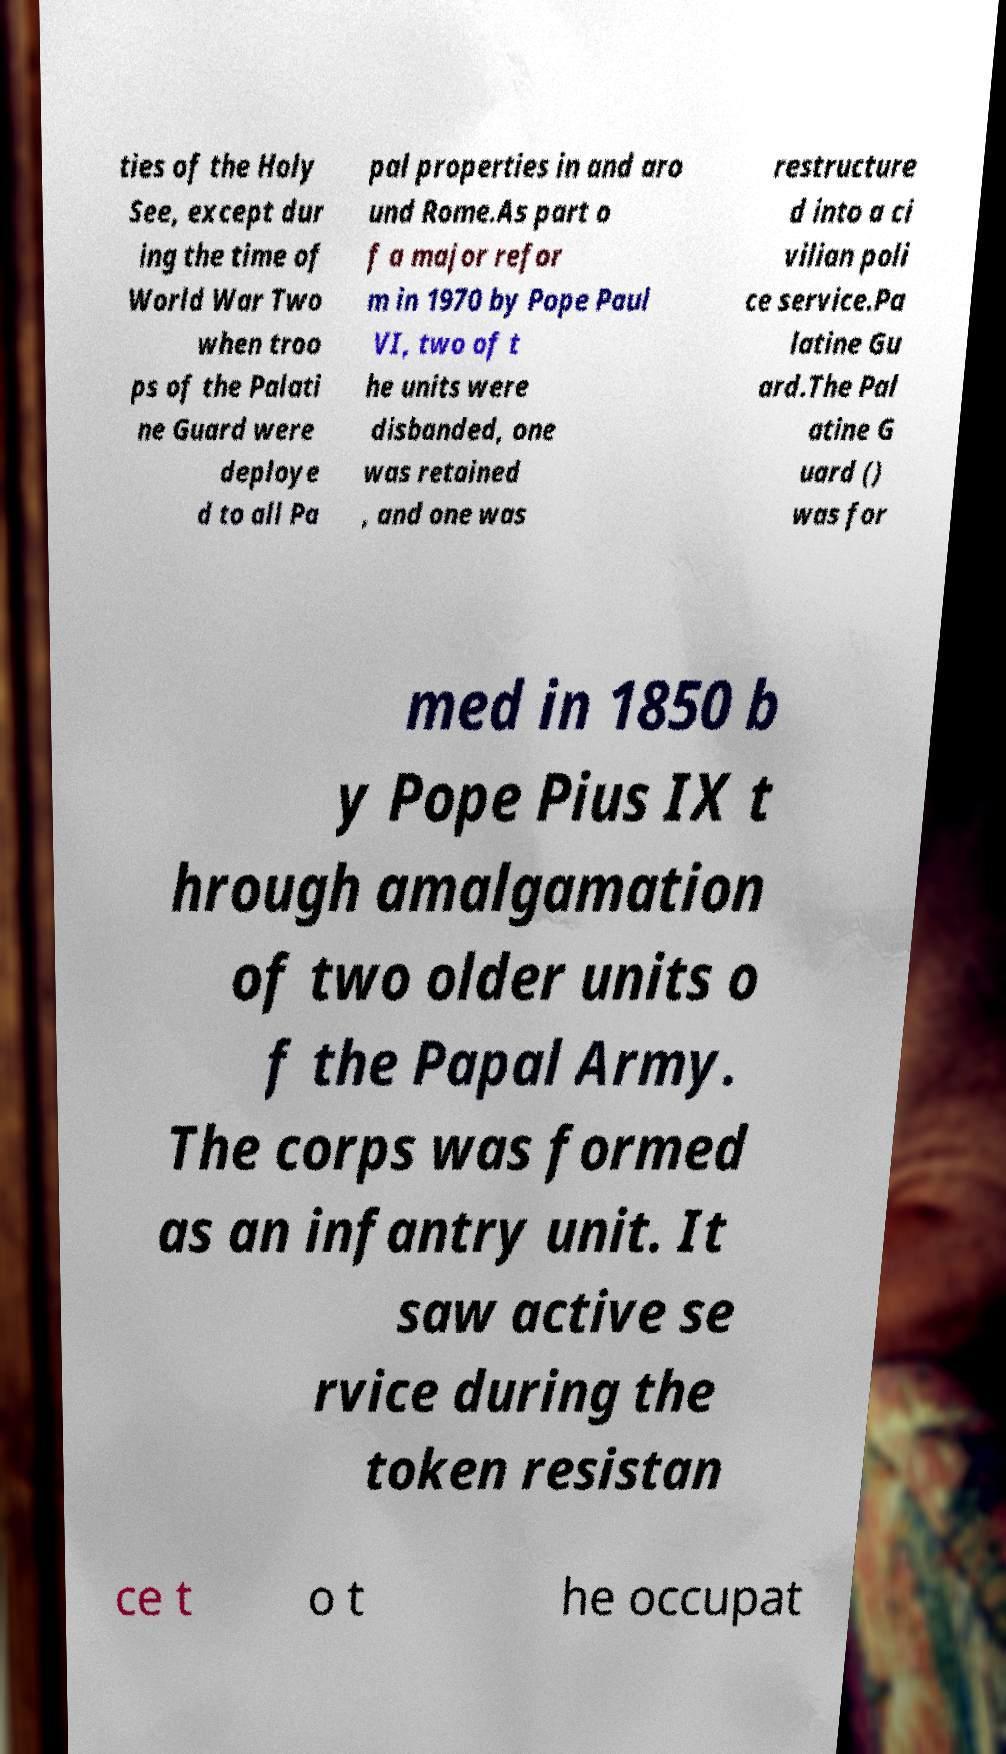What messages or text are displayed in this image? I need them in a readable, typed format. ties of the Holy See, except dur ing the time of World War Two when troo ps of the Palati ne Guard were deploye d to all Pa pal properties in and aro und Rome.As part o f a major refor m in 1970 by Pope Paul VI, two of t he units were disbanded, one was retained , and one was restructure d into a ci vilian poli ce service.Pa latine Gu ard.The Pal atine G uard () was for med in 1850 b y Pope Pius IX t hrough amalgamation of two older units o f the Papal Army. The corps was formed as an infantry unit. It saw active se rvice during the token resistan ce t o t he occupat 